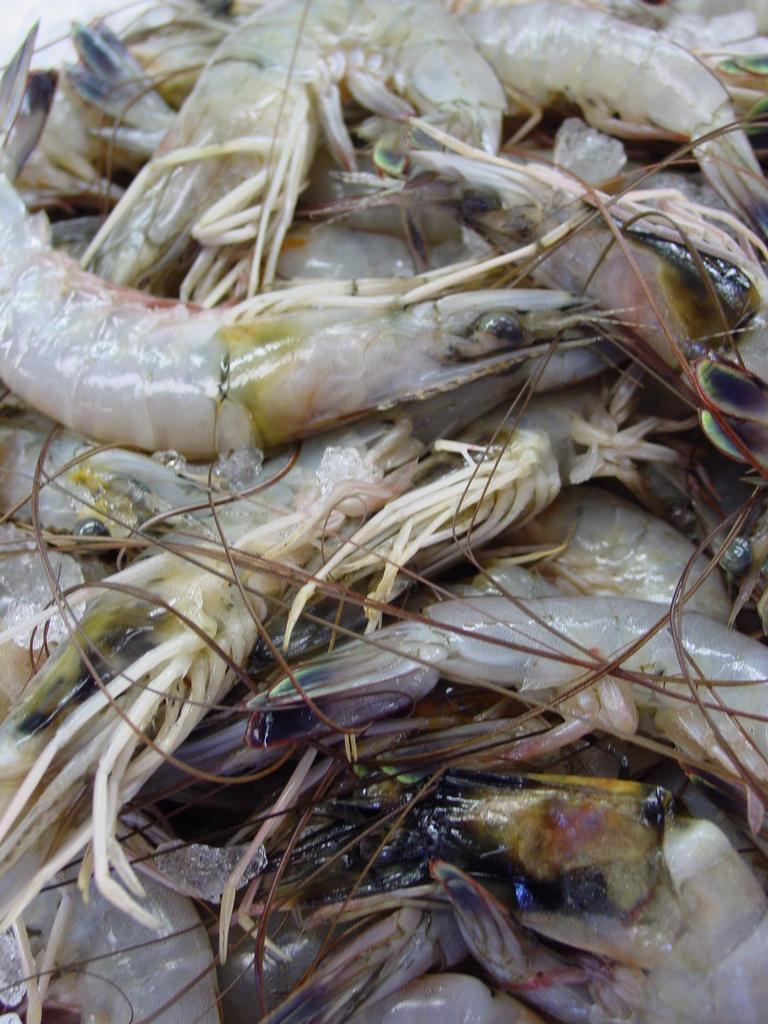What type of seafood can be seen in the image? There are multiple prawns in the image. How many prawns are visible in the image? The number of prawns is not specified, but there are multiple prawns present. What is the color of the prawns in the image? The color of the prawns is not mentioned in the facts provided. What type of debt is being discussed in the image? There is no mention of debt in the image, as it features multiple prawns. How does the payment system work for the prawns in the image? There is no payment system or transaction related to the prawns in the image, as it is a still image of seafood. 